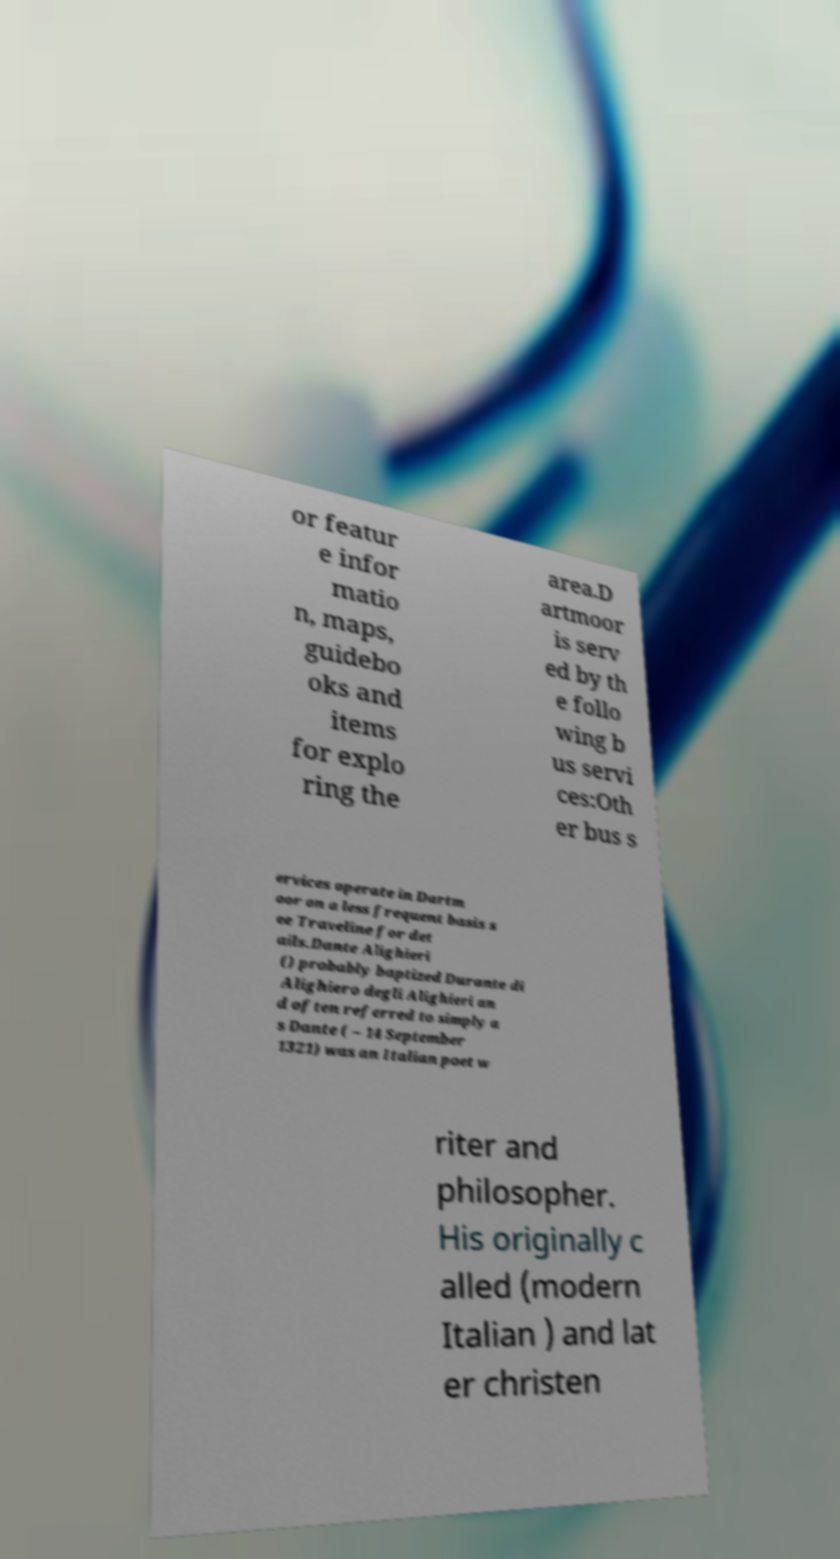Please identify and transcribe the text found in this image. or featur e infor matio n, maps, guidebo oks and items for explo ring the area.D artmoor is serv ed by th e follo wing b us servi ces:Oth er bus s ervices operate in Dartm oor on a less frequent basis s ee Traveline for det ails.Dante Alighieri () probably baptized Durante di Alighiero degli Alighieri an d often referred to simply a s Dante ( – 14 September 1321) was an Italian poet w riter and philosopher. His originally c alled (modern Italian ) and lat er christen 